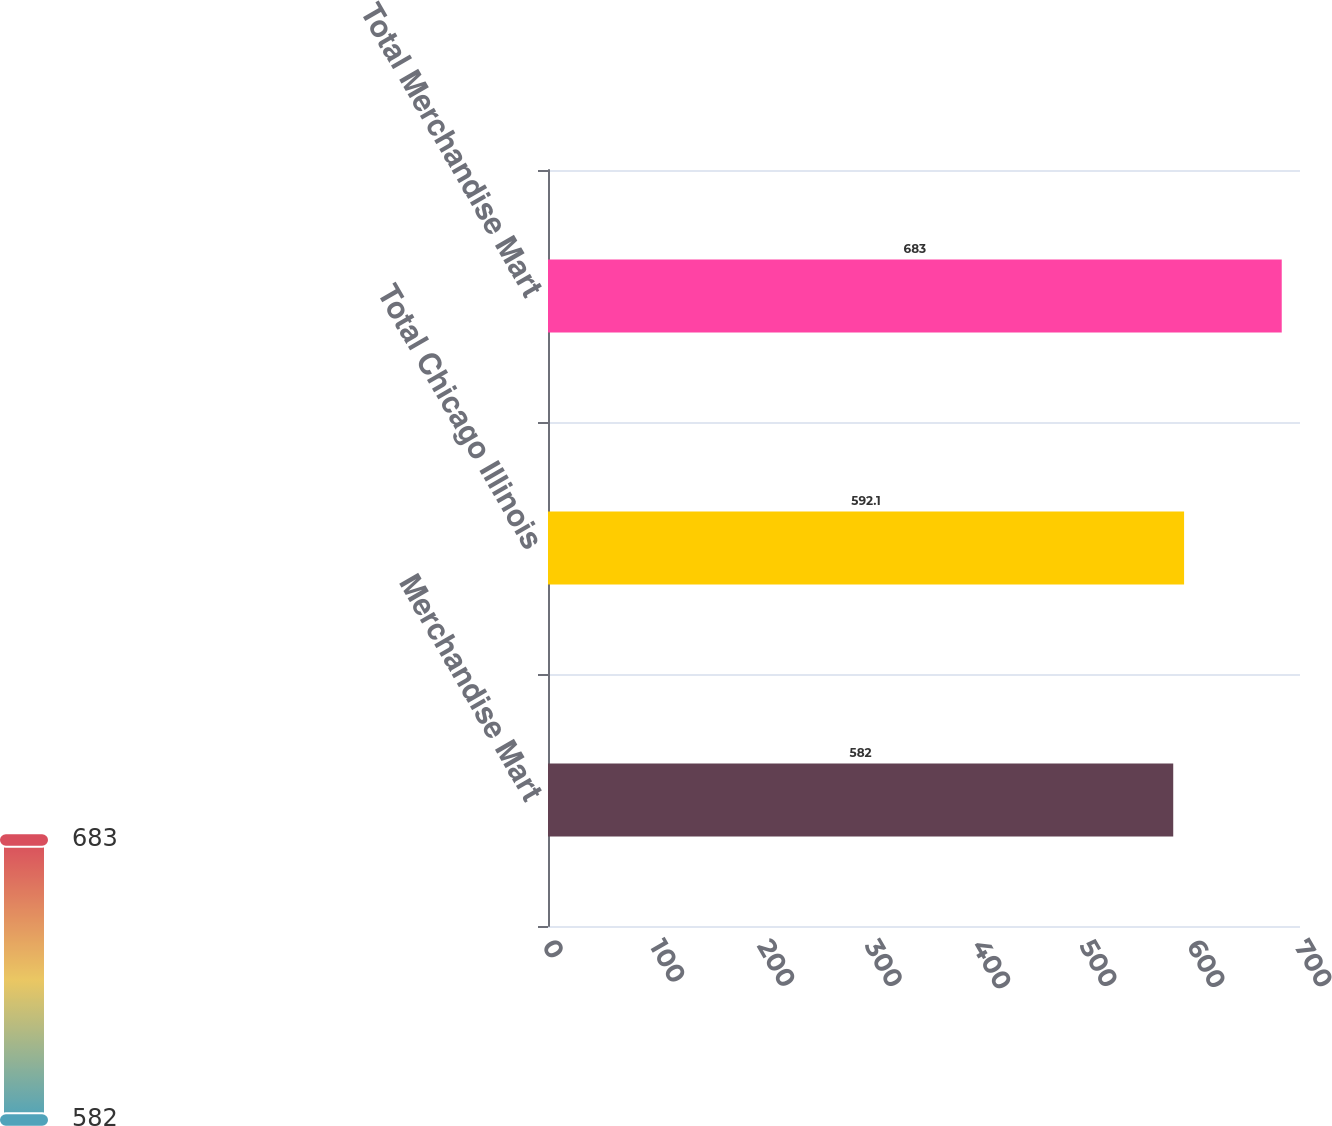Convert chart to OTSL. <chart><loc_0><loc_0><loc_500><loc_500><bar_chart><fcel>Merchandise Mart<fcel>Total Chicago Illinois<fcel>Total Merchandise Mart<nl><fcel>582<fcel>592.1<fcel>683<nl></chart> 